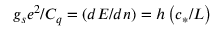Convert formula to latex. <formula><loc_0><loc_0><loc_500><loc_500>g _ { s } e ^ { 2 } / C _ { q } = \left ( d E / d n \right ) = h \left ( c _ { * } / L \right )</formula> 